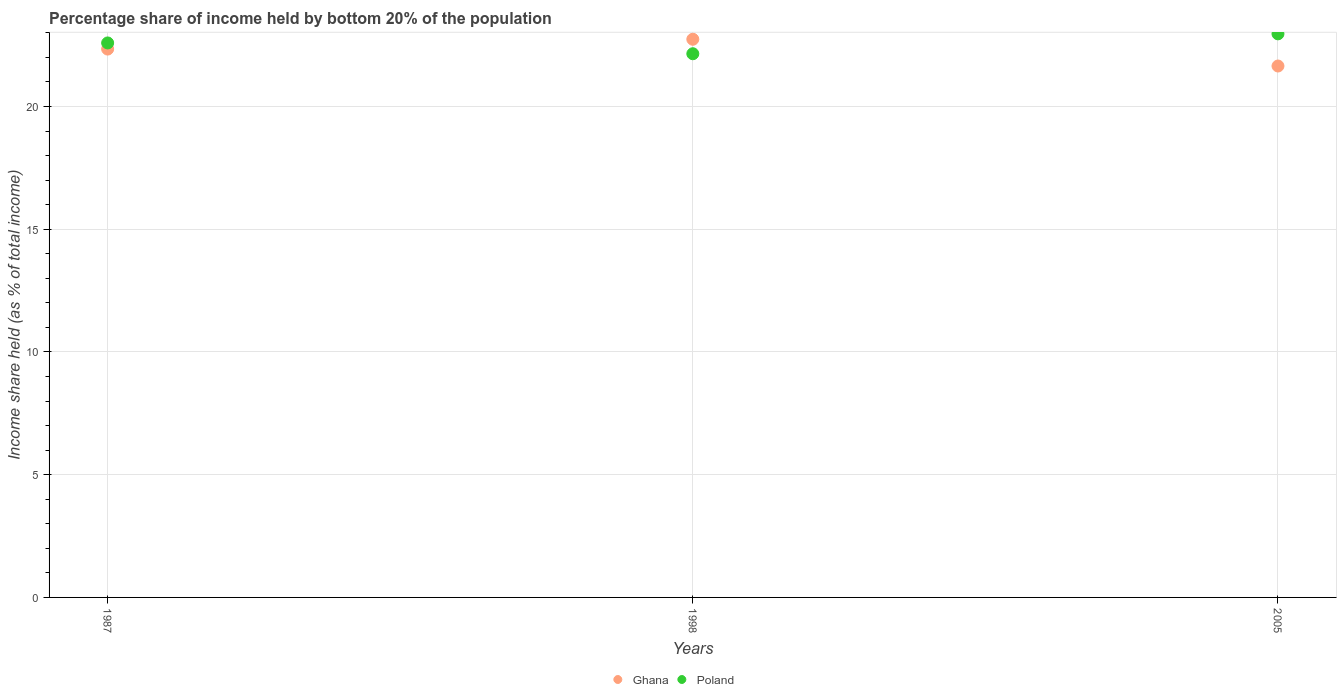What is the share of income held by bottom 20% of the population in Poland in 2005?
Offer a terse response. 22.96. Across all years, what is the maximum share of income held by bottom 20% of the population in Ghana?
Give a very brief answer. 22.74. Across all years, what is the minimum share of income held by bottom 20% of the population in Ghana?
Your answer should be very brief. 21.65. In which year was the share of income held by bottom 20% of the population in Ghana maximum?
Provide a succinct answer. 1998. What is the total share of income held by bottom 20% of the population in Poland in the graph?
Give a very brief answer. 67.7. What is the difference between the share of income held by bottom 20% of the population in Poland in 1987 and that in 1998?
Ensure brevity in your answer.  0.44. What is the difference between the share of income held by bottom 20% of the population in Ghana in 2005 and the share of income held by bottom 20% of the population in Poland in 1987?
Your answer should be compact. -0.94. What is the average share of income held by bottom 20% of the population in Ghana per year?
Offer a terse response. 22.24. In the year 1987, what is the difference between the share of income held by bottom 20% of the population in Ghana and share of income held by bottom 20% of the population in Poland?
Keep it short and to the point. -0.25. In how many years, is the share of income held by bottom 20% of the population in Ghana greater than 13 %?
Your answer should be very brief. 3. What is the ratio of the share of income held by bottom 20% of the population in Poland in 1987 to that in 1998?
Give a very brief answer. 1.02. Is the share of income held by bottom 20% of the population in Poland in 1987 less than that in 1998?
Ensure brevity in your answer.  No. Is the difference between the share of income held by bottom 20% of the population in Ghana in 1987 and 1998 greater than the difference between the share of income held by bottom 20% of the population in Poland in 1987 and 1998?
Provide a short and direct response. No. What is the difference between the highest and the second highest share of income held by bottom 20% of the population in Poland?
Make the answer very short. 0.37. What is the difference between the highest and the lowest share of income held by bottom 20% of the population in Poland?
Your answer should be very brief. 0.81. In how many years, is the share of income held by bottom 20% of the population in Poland greater than the average share of income held by bottom 20% of the population in Poland taken over all years?
Provide a succinct answer. 2. Does the share of income held by bottom 20% of the population in Ghana monotonically increase over the years?
Keep it short and to the point. No. Is the share of income held by bottom 20% of the population in Poland strictly greater than the share of income held by bottom 20% of the population in Ghana over the years?
Your answer should be compact. No. How many dotlines are there?
Make the answer very short. 2. How many years are there in the graph?
Ensure brevity in your answer.  3. What is the difference between two consecutive major ticks on the Y-axis?
Ensure brevity in your answer.  5. Are the values on the major ticks of Y-axis written in scientific E-notation?
Your answer should be compact. No. Does the graph contain any zero values?
Ensure brevity in your answer.  No. Does the graph contain grids?
Make the answer very short. Yes. What is the title of the graph?
Your answer should be very brief. Percentage share of income held by bottom 20% of the population. Does "Sierra Leone" appear as one of the legend labels in the graph?
Provide a short and direct response. No. What is the label or title of the X-axis?
Provide a succinct answer. Years. What is the label or title of the Y-axis?
Provide a succinct answer. Income share held (as % of total income). What is the Income share held (as % of total income) in Ghana in 1987?
Provide a short and direct response. 22.34. What is the Income share held (as % of total income) of Poland in 1987?
Your response must be concise. 22.59. What is the Income share held (as % of total income) of Ghana in 1998?
Provide a short and direct response. 22.74. What is the Income share held (as % of total income) of Poland in 1998?
Provide a short and direct response. 22.15. What is the Income share held (as % of total income) in Ghana in 2005?
Your response must be concise. 21.65. What is the Income share held (as % of total income) of Poland in 2005?
Your answer should be compact. 22.96. Across all years, what is the maximum Income share held (as % of total income) of Ghana?
Your answer should be very brief. 22.74. Across all years, what is the maximum Income share held (as % of total income) in Poland?
Your response must be concise. 22.96. Across all years, what is the minimum Income share held (as % of total income) in Ghana?
Your answer should be compact. 21.65. Across all years, what is the minimum Income share held (as % of total income) in Poland?
Make the answer very short. 22.15. What is the total Income share held (as % of total income) in Ghana in the graph?
Your answer should be very brief. 66.73. What is the total Income share held (as % of total income) of Poland in the graph?
Your response must be concise. 67.7. What is the difference between the Income share held (as % of total income) of Ghana in 1987 and that in 1998?
Offer a terse response. -0.4. What is the difference between the Income share held (as % of total income) of Poland in 1987 and that in 1998?
Your response must be concise. 0.44. What is the difference between the Income share held (as % of total income) of Ghana in 1987 and that in 2005?
Make the answer very short. 0.69. What is the difference between the Income share held (as % of total income) of Poland in 1987 and that in 2005?
Make the answer very short. -0.37. What is the difference between the Income share held (as % of total income) in Ghana in 1998 and that in 2005?
Your answer should be compact. 1.09. What is the difference between the Income share held (as % of total income) of Poland in 1998 and that in 2005?
Your response must be concise. -0.81. What is the difference between the Income share held (as % of total income) in Ghana in 1987 and the Income share held (as % of total income) in Poland in 1998?
Your answer should be very brief. 0.19. What is the difference between the Income share held (as % of total income) in Ghana in 1987 and the Income share held (as % of total income) in Poland in 2005?
Provide a succinct answer. -0.62. What is the difference between the Income share held (as % of total income) of Ghana in 1998 and the Income share held (as % of total income) of Poland in 2005?
Provide a short and direct response. -0.22. What is the average Income share held (as % of total income) in Ghana per year?
Your answer should be very brief. 22.24. What is the average Income share held (as % of total income) of Poland per year?
Ensure brevity in your answer.  22.57. In the year 1987, what is the difference between the Income share held (as % of total income) of Ghana and Income share held (as % of total income) of Poland?
Make the answer very short. -0.25. In the year 1998, what is the difference between the Income share held (as % of total income) in Ghana and Income share held (as % of total income) in Poland?
Your response must be concise. 0.59. In the year 2005, what is the difference between the Income share held (as % of total income) in Ghana and Income share held (as % of total income) in Poland?
Keep it short and to the point. -1.31. What is the ratio of the Income share held (as % of total income) in Ghana in 1987 to that in 1998?
Offer a very short reply. 0.98. What is the ratio of the Income share held (as % of total income) of Poland in 1987 to that in 1998?
Ensure brevity in your answer.  1.02. What is the ratio of the Income share held (as % of total income) in Ghana in 1987 to that in 2005?
Your answer should be compact. 1.03. What is the ratio of the Income share held (as % of total income) in Poland in 1987 to that in 2005?
Offer a very short reply. 0.98. What is the ratio of the Income share held (as % of total income) of Ghana in 1998 to that in 2005?
Provide a short and direct response. 1.05. What is the ratio of the Income share held (as % of total income) of Poland in 1998 to that in 2005?
Your response must be concise. 0.96. What is the difference between the highest and the second highest Income share held (as % of total income) of Poland?
Offer a very short reply. 0.37. What is the difference between the highest and the lowest Income share held (as % of total income) of Ghana?
Your answer should be compact. 1.09. What is the difference between the highest and the lowest Income share held (as % of total income) of Poland?
Your answer should be very brief. 0.81. 